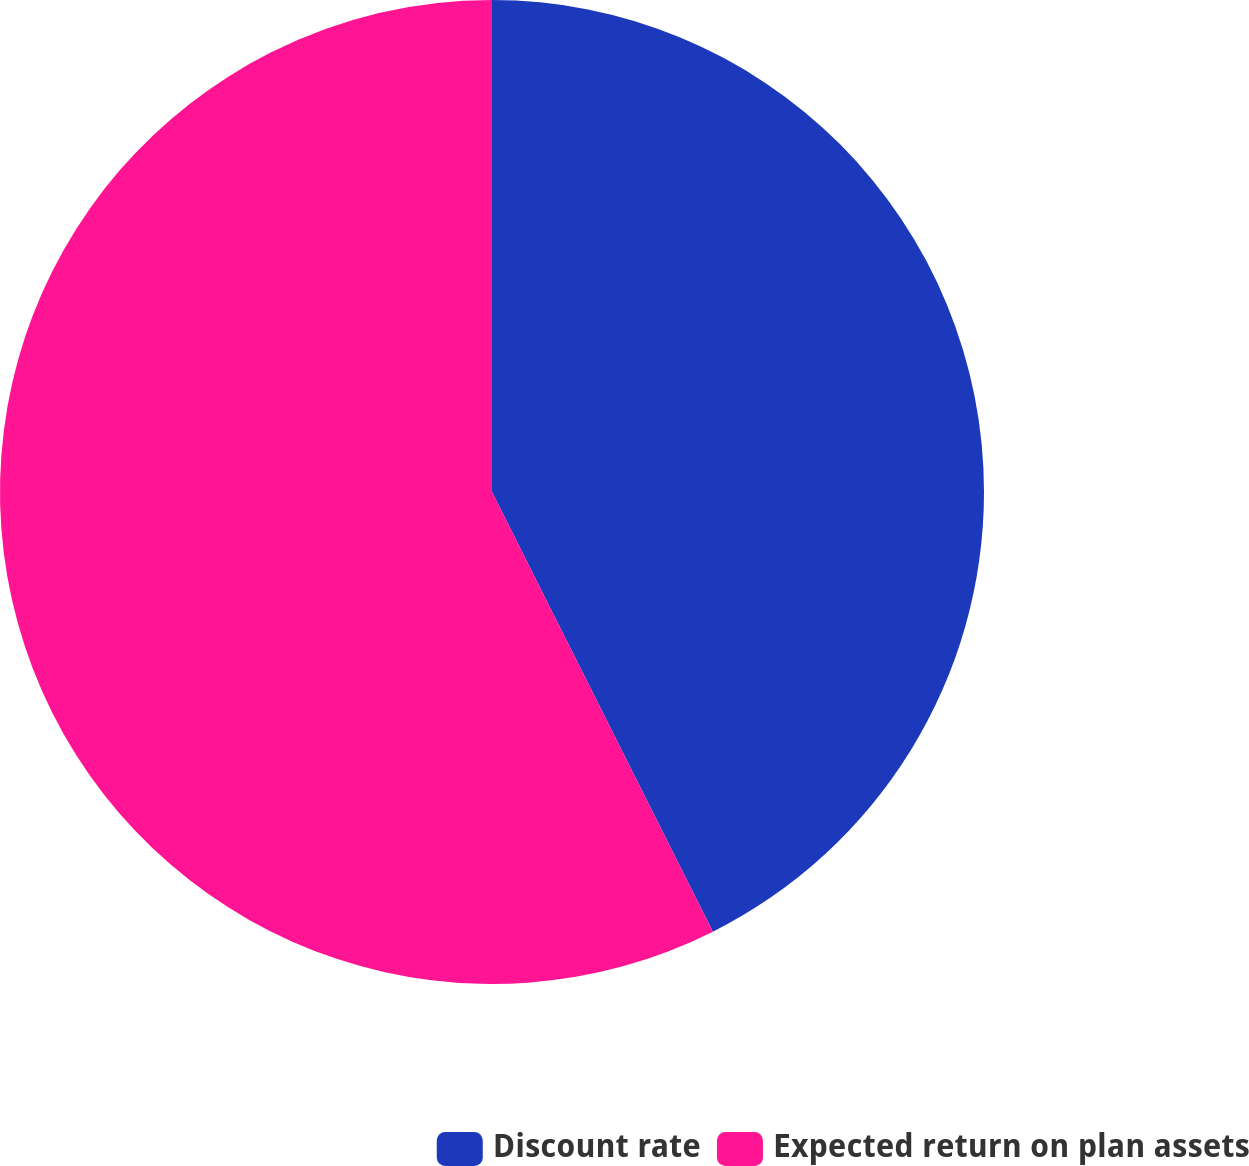Convert chart to OTSL. <chart><loc_0><loc_0><loc_500><loc_500><pie_chart><fcel>Discount rate<fcel>Expected return on plan assets<nl><fcel>42.59%<fcel>57.41%<nl></chart> 